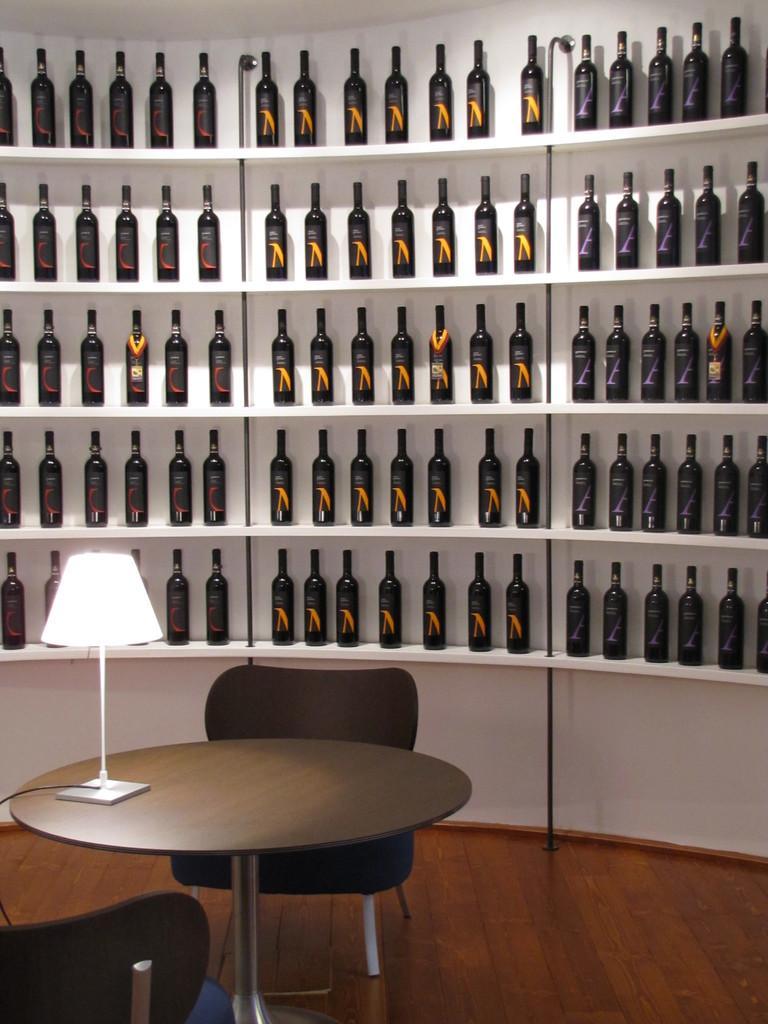In one or two sentences, can you explain what this image depicts? In the image we can see there is a shelf in which there are bottles kept and in front of it there is a table and a chair and table lamp. 